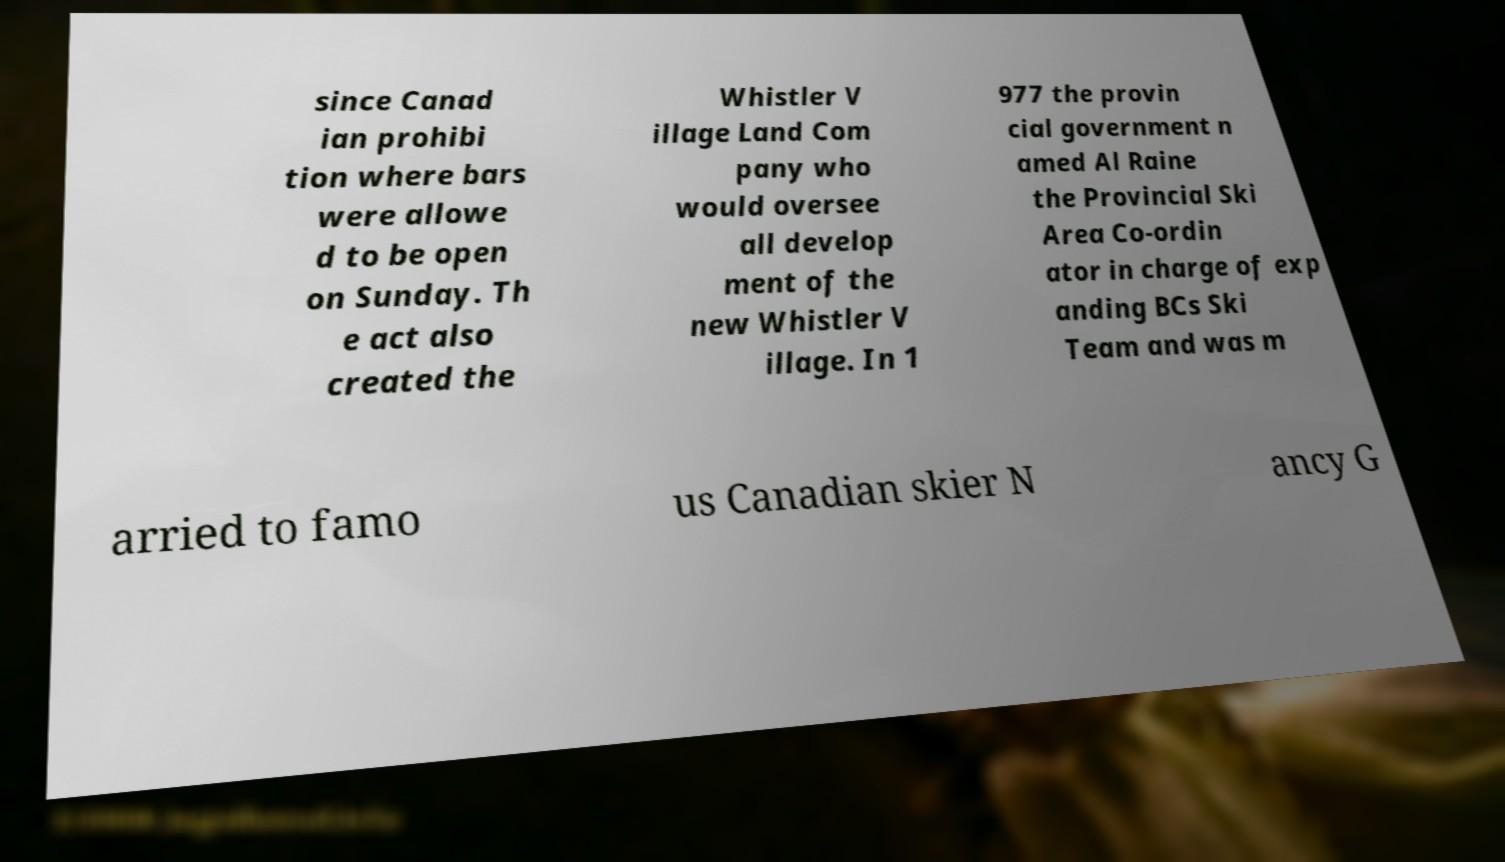Can you accurately transcribe the text from the provided image for me? since Canad ian prohibi tion where bars were allowe d to be open on Sunday. Th e act also created the Whistler V illage Land Com pany who would oversee all develop ment of the new Whistler V illage. In 1 977 the provin cial government n amed Al Raine the Provincial Ski Area Co-ordin ator in charge of exp anding BCs Ski Team and was m arried to famo us Canadian skier N ancy G 